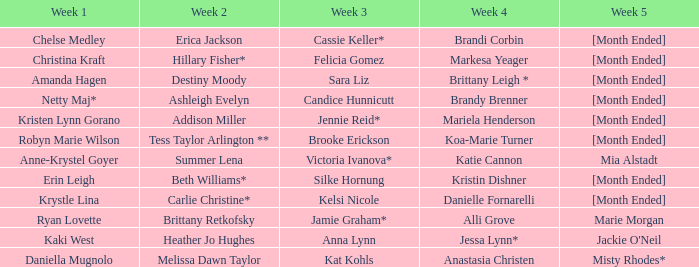What is the week 1 with candice hunnicutt in week 3? Netty Maj*. 